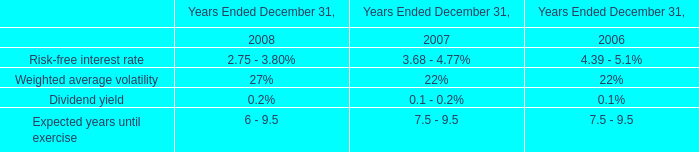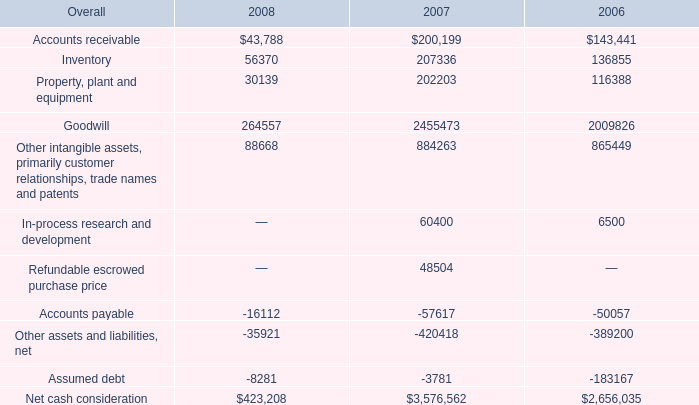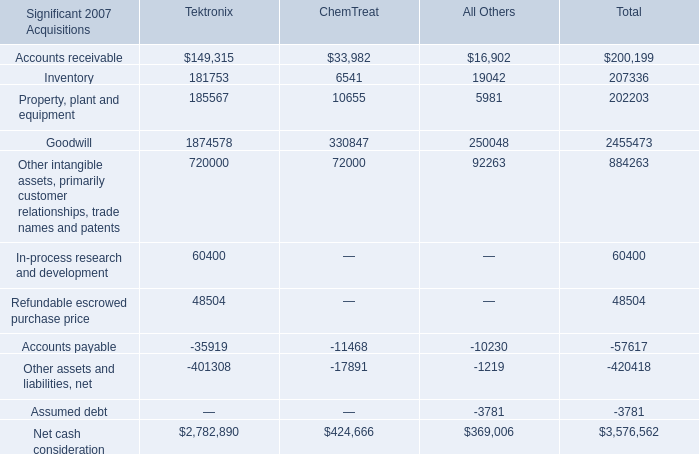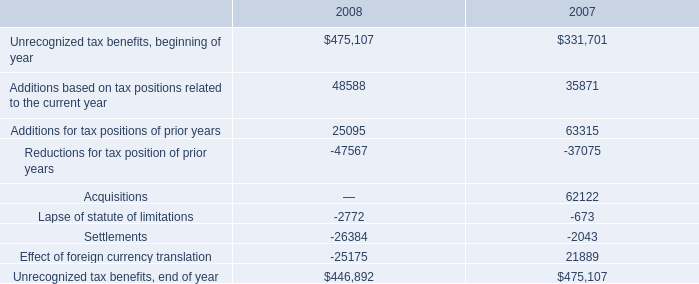What is the proportion of all Accounts receivable that are greater than 100000 to the total amount of Accounts receivable, in 2007? 
Computations: (149315 / 200199)
Answer: 0.74583. 